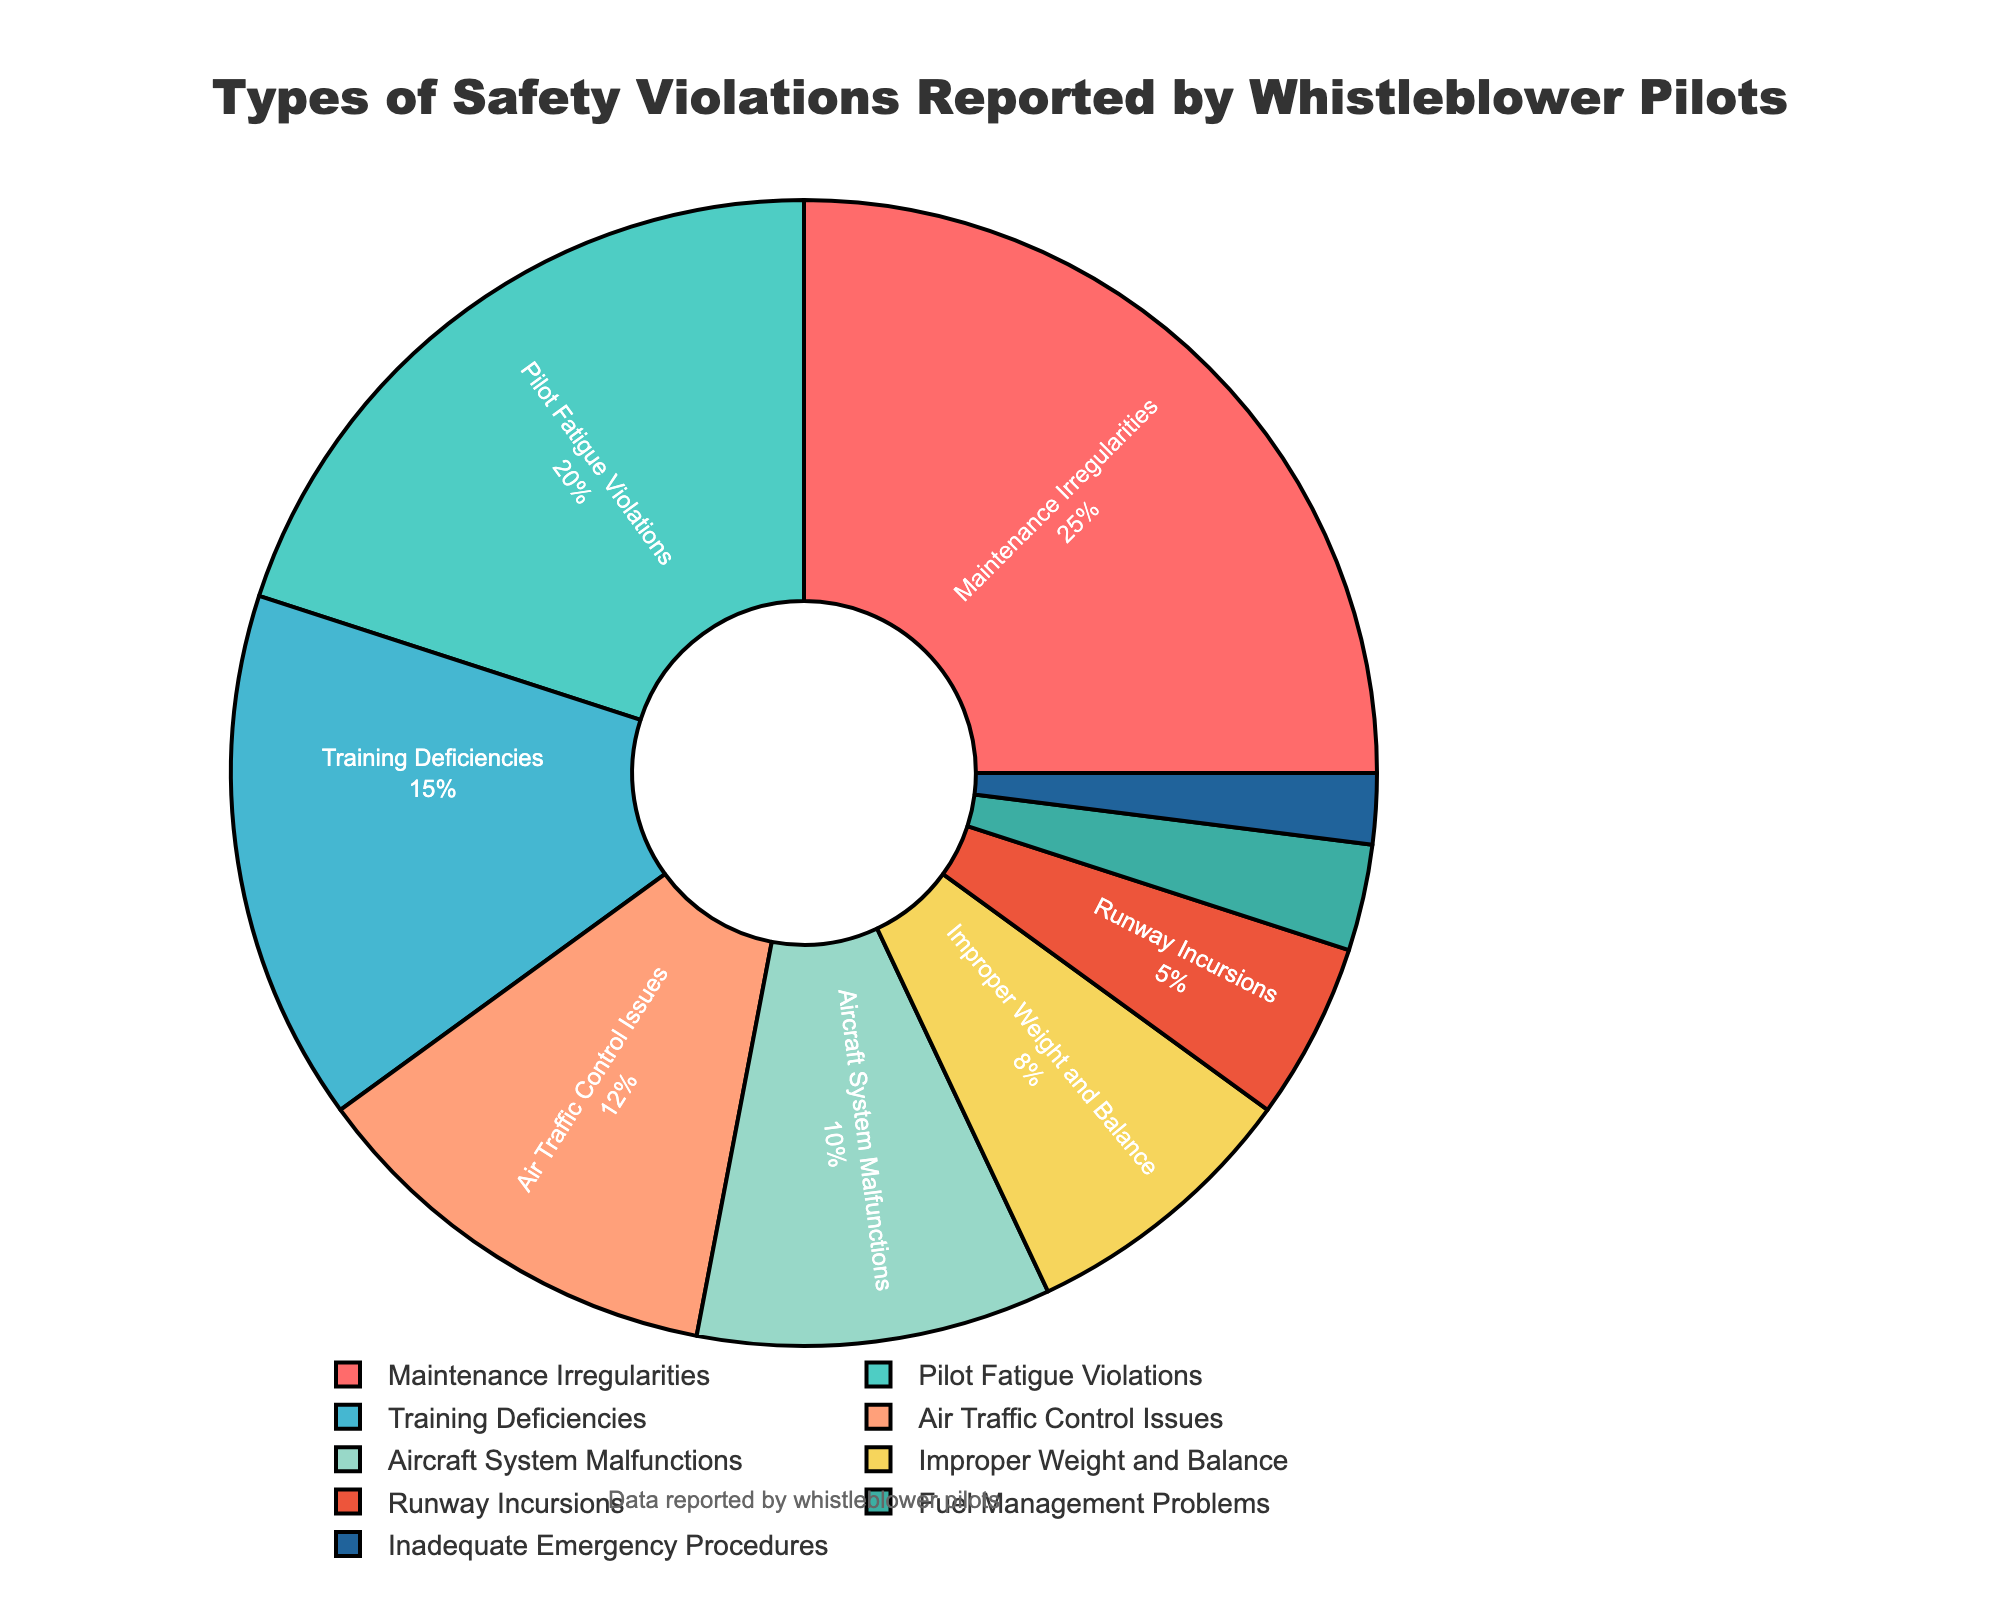What is the most commonly reported type of safety violation? The most commonly reported type of safety violation is the one with the highest percentage value. From the pie chart, Maintenance Irregularities has the highest percentage.
Answer: Maintenance Irregularities Which type of safety violation is reported the least? The type of safety violation with the smallest percentage segment is the one reported the least. According to the pie chart, Inadequate Emergency Procedures has the smallest percentage.
Answer: Inadequate Emergency Procedures What is the total percentage of Training Deficiencies and Air Traffic Control Issues combined? To find the total percentage, sum the values of Training Deficiencies and Air Traffic Control Issues: 15% + 12% = 27%.
Answer: 27% How much larger is the percentage of Maintenance Irregularities compared to Fuel Management Problems? Subtract the percentage of Fuel Management Problems from the percentage of Maintenance Irregularities: 25% - 3% = 22%.
Answer: 22% Which type of violation is just above Pilot Fatigue Violations in terms of percentage? Locate Pilot Fatigue Violations in the pie chart, then identify the segment immediately larger than it. Maintenance Irregularities is just above Pilot Fatigue Violations.
Answer: Maintenance Irregularities What percentage of violations are due to Aircraft System Malfunctions and Improper Weight and Balance combined? Sum the percentages of Aircraft System Malfunctions and Improper Weight and Balance: 10% + 8% = 18%.
Answer: 18% Is the percentage of Runway Incursions greater than that of Fuel Management Problems? Compare the percentages of Runway Incursions and Fuel Management Problems. Runway Incursions have 5%, and Fuel Management Problems have 3%. Hence, yes, it is greater.
Answer: Yes How does the percentage of Training Deficiencies compare to Pilot Fatigue Violations? Compare the percentages directly. Training Deficiencies have 15%, and Pilot Fatigue Violations have 20%. Training Deficiencies are less than Pilot Fatigue Violations.
Answer: Less than Which violation types combined account for more than half of all reported violations? Sum the percentages until the total exceeds 50%. Maintenance Irregularities (25%) + Pilot Fatigue Violations (20%) + Training Deficiencies (15%) = 60%. Maintenance Irregularities, Pilot Fatigue Violations, and Training Deficiencies together account for more than half.
Answer: Maintenance Irregularities, Pilot Fatigue Violations, Training Deficiencies What are the colors used for the three most common violations, and what are their corresponding violation types? Identify the segments with the highest percentages and their colors. Maintenance Irregularities (red), Pilot Fatigue Violations (green), and Training Deficiencies (light blue).
Answer: Red (Maintenance Irregularities), Green (Pilot Fatigue Violations), Light Blue (Training Deficiencies) 